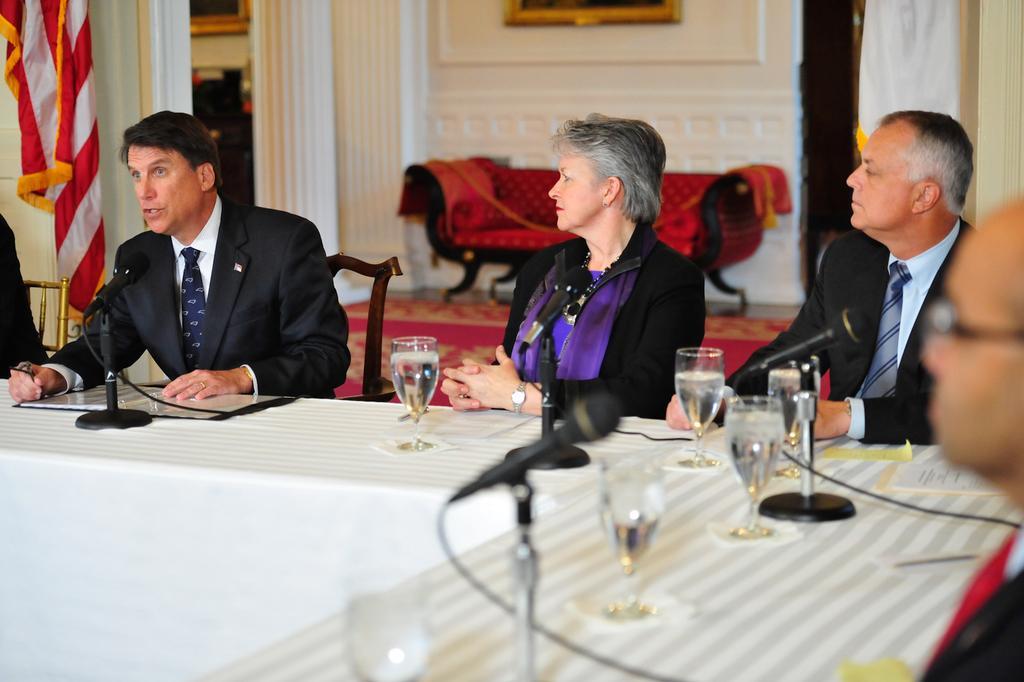Can you describe this image briefly? In this image I can see few persons sitting. I can see a table. I can see few glasses and mics on the table. In the background I can see a chair. I can see a wall. 